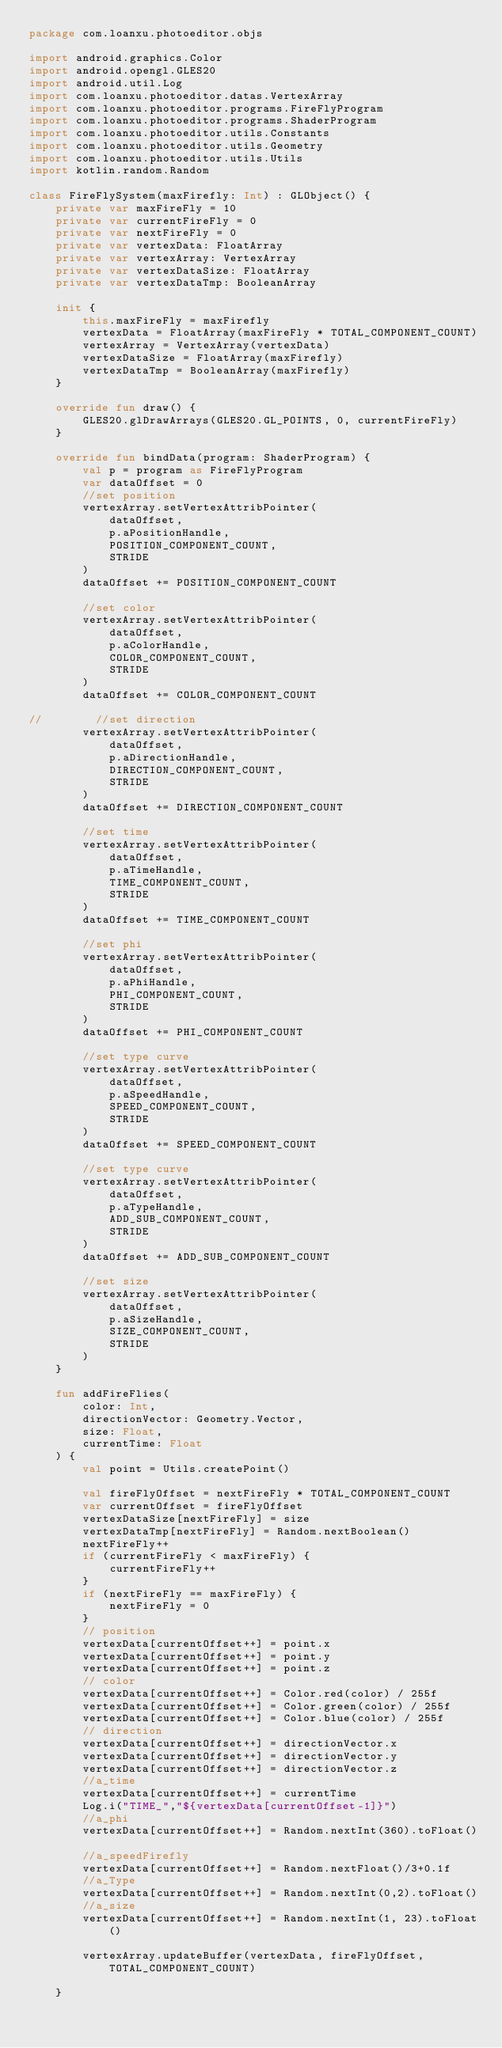Convert code to text. <code><loc_0><loc_0><loc_500><loc_500><_Kotlin_>package com.loanxu.photoeditor.objs

import android.graphics.Color
import android.opengl.GLES20
import android.util.Log
import com.loanxu.photoeditor.datas.VertexArray
import com.loanxu.photoeditor.programs.FireFlyProgram
import com.loanxu.photoeditor.programs.ShaderProgram
import com.loanxu.photoeditor.utils.Constants
import com.loanxu.photoeditor.utils.Geometry
import com.loanxu.photoeditor.utils.Utils
import kotlin.random.Random

class FireFlySystem(maxFirefly: Int) : GLObject() {
    private var maxFireFly = 10
    private var currentFireFly = 0
    private var nextFireFly = 0
    private var vertexData: FloatArray
    private var vertexArray: VertexArray
    private var vertexDataSize: FloatArray
    private var vertexDataTmp: BooleanArray

    init {
        this.maxFireFly = maxFirefly
        vertexData = FloatArray(maxFireFly * TOTAL_COMPONENT_COUNT)
        vertexArray = VertexArray(vertexData)
        vertexDataSize = FloatArray(maxFirefly)
        vertexDataTmp = BooleanArray(maxFirefly)
    }

    override fun draw() {
        GLES20.glDrawArrays(GLES20.GL_POINTS, 0, currentFireFly)
    }

    override fun bindData(program: ShaderProgram) {
        val p = program as FireFlyProgram
        var dataOffset = 0
        //set position
        vertexArray.setVertexAttribPointer(
            dataOffset,
            p.aPositionHandle,
            POSITION_COMPONENT_COUNT,
            STRIDE
        )
        dataOffset += POSITION_COMPONENT_COUNT

        //set color
        vertexArray.setVertexAttribPointer(
            dataOffset,
            p.aColorHandle,
            COLOR_COMPONENT_COUNT,
            STRIDE
        )
        dataOffset += COLOR_COMPONENT_COUNT

//        //set direction
        vertexArray.setVertexAttribPointer(
            dataOffset,
            p.aDirectionHandle,
            DIRECTION_COMPONENT_COUNT,
            STRIDE
        )
        dataOffset += DIRECTION_COMPONENT_COUNT

        //set time
        vertexArray.setVertexAttribPointer(
            dataOffset,
            p.aTimeHandle,
            TIME_COMPONENT_COUNT,
            STRIDE
        )
        dataOffset += TIME_COMPONENT_COUNT

        //set phi
        vertexArray.setVertexAttribPointer(
            dataOffset,
            p.aPhiHandle,
            PHI_COMPONENT_COUNT,
            STRIDE
        )
        dataOffset += PHI_COMPONENT_COUNT

        //set type curve
        vertexArray.setVertexAttribPointer(
            dataOffset,
            p.aSpeedHandle,
            SPEED_COMPONENT_COUNT,
            STRIDE
        )
        dataOffset += SPEED_COMPONENT_COUNT

        //set type curve
        vertexArray.setVertexAttribPointer(
            dataOffset,
            p.aTypeHandle,
            ADD_SUB_COMPONENT_COUNT,
            STRIDE
        )
        dataOffset += ADD_SUB_COMPONENT_COUNT

        //set size
        vertexArray.setVertexAttribPointer(
            dataOffset,
            p.aSizeHandle,
            SIZE_COMPONENT_COUNT,
            STRIDE
        )
    }

    fun addFireFlies(
        color: Int,
        directionVector: Geometry.Vector,
        size: Float,
        currentTime: Float
    ) {
        val point = Utils.createPoint()

        val fireFlyOffset = nextFireFly * TOTAL_COMPONENT_COUNT
        var currentOffset = fireFlyOffset
        vertexDataSize[nextFireFly] = size
        vertexDataTmp[nextFireFly] = Random.nextBoolean()
        nextFireFly++
        if (currentFireFly < maxFireFly) {
            currentFireFly++
        }
        if (nextFireFly == maxFireFly) {
            nextFireFly = 0
        }
        // position
        vertexData[currentOffset++] = point.x
        vertexData[currentOffset++] = point.y
        vertexData[currentOffset++] = point.z
        // color
        vertexData[currentOffset++] = Color.red(color) / 255f
        vertexData[currentOffset++] = Color.green(color) / 255f
        vertexData[currentOffset++] = Color.blue(color) / 255f
        // direction
        vertexData[currentOffset++] = directionVector.x
        vertexData[currentOffset++] = directionVector.y
        vertexData[currentOffset++] = directionVector.z
        //a_time
        vertexData[currentOffset++] = currentTime
        Log.i("TIME_","${vertexData[currentOffset-1]}")
        //a_phi
        vertexData[currentOffset++] = Random.nextInt(360).toFloat()

        //a_speedFirefly
        vertexData[currentOffset++] = Random.nextFloat()/3+0.1f
        //a_Type
        vertexData[currentOffset++] = Random.nextInt(0,2).toFloat()
        //a_size
        vertexData[currentOffset++] = Random.nextInt(1, 23).toFloat()

        vertexArray.updateBuffer(vertexData, fireFlyOffset, TOTAL_COMPONENT_COUNT)

    }
</code> 